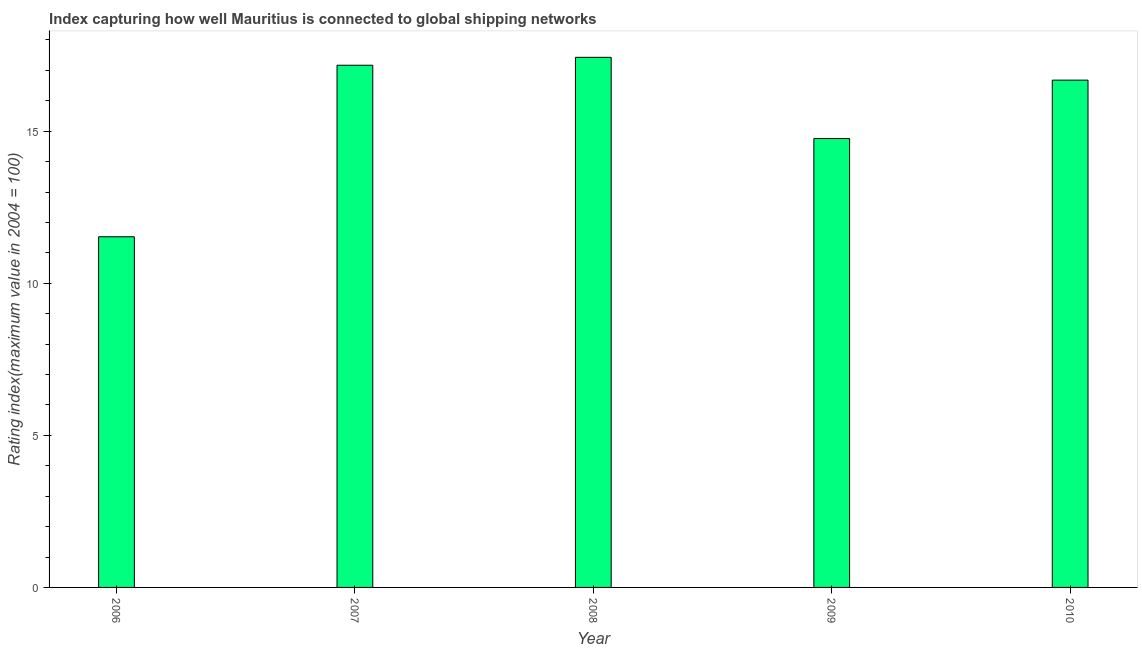Does the graph contain any zero values?
Give a very brief answer. No. What is the title of the graph?
Offer a terse response. Index capturing how well Mauritius is connected to global shipping networks. What is the label or title of the X-axis?
Provide a succinct answer. Year. What is the label or title of the Y-axis?
Offer a terse response. Rating index(maximum value in 2004 = 100). What is the liner shipping connectivity index in 2006?
Offer a terse response. 11.53. Across all years, what is the maximum liner shipping connectivity index?
Offer a terse response. 17.43. Across all years, what is the minimum liner shipping connectivity index?
Your answer should be very brief. 11.53. What is the sum of the liner shipping connectivity index?
Provide a short and direct response. 77.57. What is the difference between the liner shipping connectivity index in 2007 and 2008?
Make the answer very short. -0.26. What is the average liner shipping connectivity index per year?
Your answer should be compact. 15.51. What is the median liner shipping connectivity index?
Keep it short and to the point. 16.68. In how many years, is the liner shipping connectivity index greater than 9 ?
Ensure brevity in your answer.  5. Do a majority of the years between 2009 and 2010 (inclusive) have liner shipping connectivity index greater than 15 ?
Your answer should be very brief. No. What is the ratio of the liner shipping connectivity index in 2008 to that in 2010?
Your response must be concise. 1.04. Is the difference between the liner shipping connectivity index in 2006 and 2009 greater than the difference between any two years?
Your answer should be compact. No. What is the difference between the highest and the second highest liner shipping connectivity index?
Provide a short and direct response. 0.26. Is the sum of the liner shipping connectivity index in 2007 and 2008 greater than the maximum liner shipping connectivity index across all years?
Your answer should be very brief. Yes. What is the difference between the highest and the lowest liner shipping connectivity index?
Your answer should be very brief. 5.9. In how many years, is the liner shipping connectivity index greater than the average liner shipping connectivity index taken over all years?
Make the answer very short. 3. What is the Rating index(maximum value in 2004 = 100) in 2006?
Provide a short and direct response. 11.53. What is the Rating index(maximum value in 2004 = 100) in 2007?
Your answer should be compact. 17.17. What is the Rating index(maximum value in 2004 = 100) of 2008?
Your answer should be compact. 17.43. What is the Rating index(maximum value in 2004 = 100) of 2009?
Give a very brief answer. 14.76. What is the Rating index(maximum value in 2004 = 100) in 2010?
Your response must be concise. 16.68. What is the difference between the Rating index(maximum value in 2004 = 100) in 2006 and 2007?
Offer a terse response. -5.64. What is the difference between the Rating index(maximum value in 2004 = 100) in 2006 and 2009?
Provide a succinct answer. -3.23. What is the difference between the Rating index(maximum value in 2004 = 100) in 2006 and 2010?
Provide a short and direct response. -5.15. What is the difference between the Rating index(maximum value in 2004 = 100) in 2007 and 2008?
Your answer should be very brief. -0.26. What is the difference between the Rating index(maximum value in 2004 = 100) in 2007 and 2009?
Give a very brief answer. 2.41. What is the difference between the Rating index(maximum value in 2004 = 100) in 2007 and 2010?
Your answer should be very brief. 0.49. What is the difference between the Rating index(maximum value in 2004 = 100) in 2008 and 2009?
Provide a succinct answer. 2.67. What is the difference between the Rating index(maximum value in 2004 = 100) in 2009 and 2010?
Give a very brief answer. -1.92. What is the ratio of the Rating index(maximum value in 2004 = 100) in 2006 to that in 2007?
Provide a succinct answer. 0.67. What is the ratio of the Rating index(maximum value in 2004 = 100) in 2006 to that in 2008?
Offer a very short reply. 0.66. What is the ratio of the Rating index(maximum value in 2004 = 100) in 2006 to that in 2009?
Provide a succinct answer. 0.78. What is the ratio of the Rating index(maximum value in 2004 = 100) in 2006 to that in 2010?
Give a very brief answer. 0.69. What is the ratio of the Rating index(maximum value in 2004 = 100) in 2007 to that in 2009?
Offer a very short reply. 1.16. What is the ratio of the Rating index(maximum value in 2004 = 100) in 2007 to that in 2010?
Offer a terse response. 1.03. What is the ratio of the Rating index(maximum value in 2004 = 100) in 2008 to that in 2009?
Offer a terse response. 1.18. What is the ratio of the Rating index(maximum value in 2004 = 100) in 2008 to that in 2010?
Offer a terse response. 1.04. What is the ratio of the Rating index(maximum value in 2004 = 100) in 2009 to that in 2010?
Make the answer very short. 0.89. 